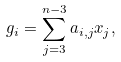<formula> <loc_0><loc_0><loc_500><loc_500>g _ { i } = \sum _ { j = 3 } ^ { n - 3 } a _ { i , j } x _ { j } ,</formula> 